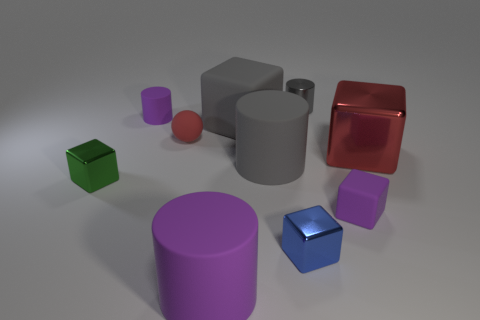What is the size of the metal object that is the same color as the large matte cube?
Your answer should be compact. Small. There is a object that is the same color as the small matte sphere; what shape is it?
Your answer should be compact. Cube. How many purple rubber objects have the same shape as the blue shiny object?
Offer a very short reply. 1. What size is the gray cylinder in front of the purple object behind the small green metallic object?
Offer a terse response. Large. Does the green cube have the same size as the red ball?
Your answer should be very brief. Yes. There is a large matte object in front of the tiny purple matte thing that is in front of the large gray rubber cylinder; are there any big matte cylinders that are right of it?
Keep it short and to the point. Yes. What size is the red shiny block?
Your response must be concise. Large. What number of gray cylinders are the same size as the green metal thing?
Your response must be concise. 1. There is a tiny gray thing that is the same shape as the big purple matte object; what is its material?
Provide a succinct answer. Metal. There is a big rubber thing that is both behind the large purple cylinder and to the left of the large gray cylinder; what shape is it?
Make the answer very short. Cube. 